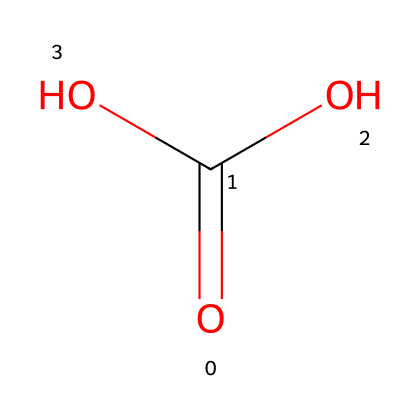How many carbon atoms are in carbonic acid? The SMILES representation shows a single carbon atom in the structure (C), which is the central atom in carbonic acid.
Answer: 1 What functional groups are present in carbonic acid? The structure indicates the presence of a carboxylic acid group, which includes a carbonyl (C=O) and a hydroxyl group (–OH).
Answer: carboxylic acid How many oxygen atoms are in carbonic acid? From the SMILES representation, there are two oxygen atoms in the structure: one in the carbonyl group and another in the hydroxyl group.
Answer: 2 Is carbonic acid considered a weak or strong acid? Carbonic acid is classified as a weak acid due to its partial dissociation in water compared to strong acids that completely dissociate.
Answer: weak What is the pH range of carbonic acid solutions? Solutions of carbonic acid typically have a pH range around 4 to 6, indicating its acidic nature but not as strongly acidic as strong acids.
Answer: 4 to 6 What effect does carbonic acid have on the taste of fizzy drinks? The presence of carbonic acid contributes a slight tangy or fizzy sensation, enhancing the refreshing taste of the beverage.
Answer: tangy Which part of the structure determines the acidic properties of carbonic acid? The hydrogen atoms bonded to the oxygen atoms (–OH) in the carboxylic acid group are responsible for its acidic properties, allowing for proton donation.
Answer: hydrogen atoms 